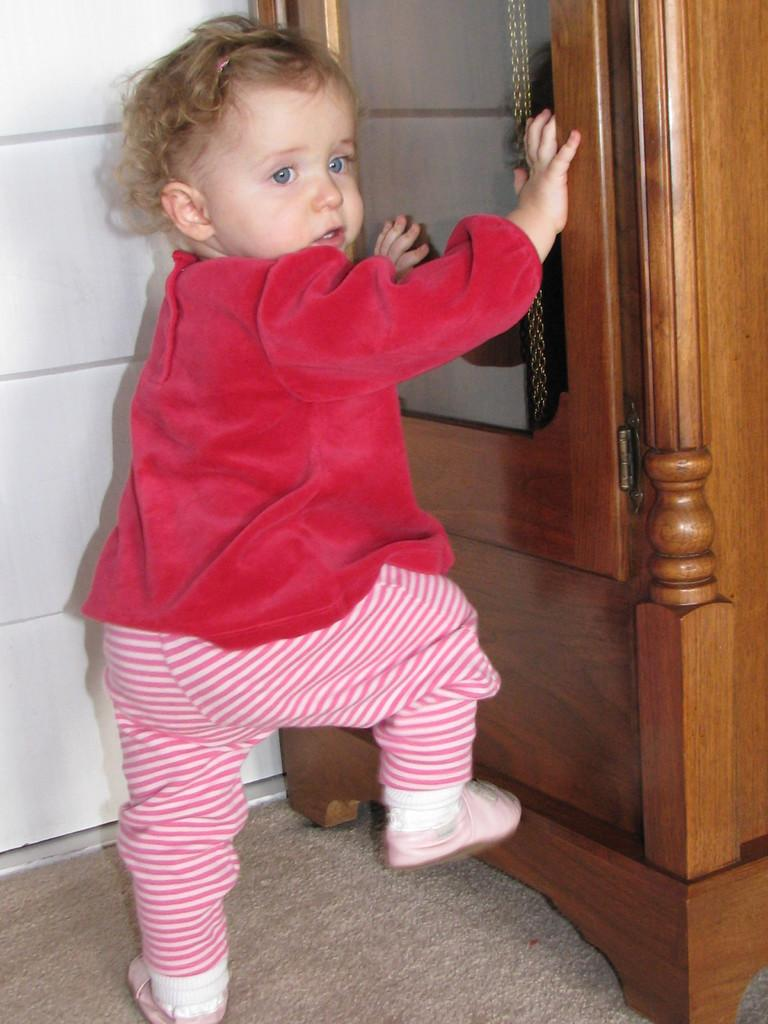What is the main subject of the image? The main subject of the image is a baby. Can you describe the baby's attire? The baby is wearing clothes and shoes. What type of furniture is present in the image? There is a wooden cabinet in the image. What type of flooring is visible in the image? There is a carpet in the image. What is the background of the image made of? There is a wall in the image. How does the baby control the tin in the image? There is no tin present in the image, so the baby cannot control it. 